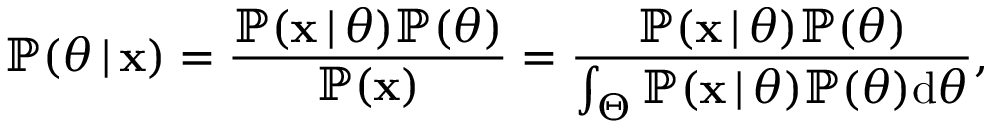Convert formula to latex. <formula><loc_0><loc_0><loc_500><loc_500>\mathbb { P } ( \theta \, | \, x ) = \frac { \mathbb { P } ( x \, | \, \theta ) \mathbb { P } ( \theta ) } { \mathbb { P } ( x ) } = \frac { \mathbb { P } ( x \, | \, \theta ) \mathbb { P } ( \theta ) } { \int _ { \Theta } \mathbb { P } ( x \, | \, \theta ) \mathbb { P } ( \theta ) d \theta } ,</formula> 